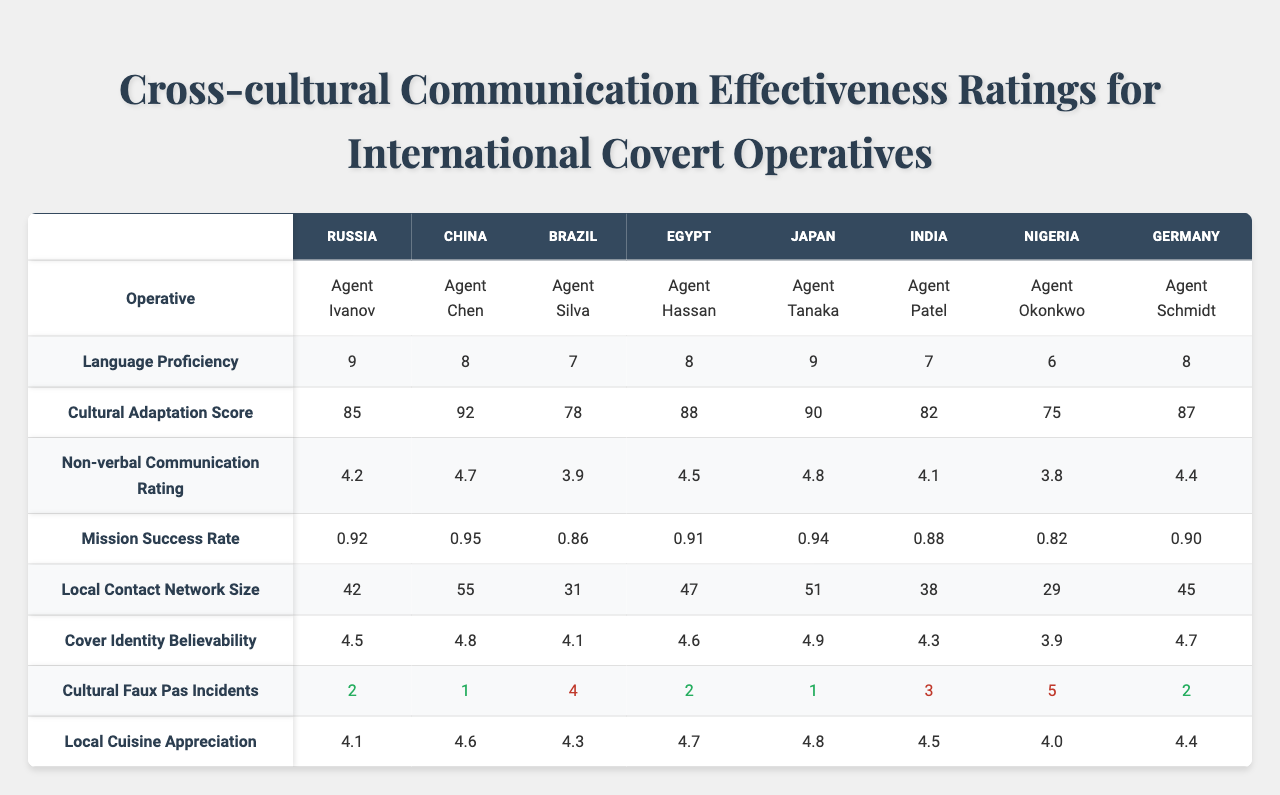What is the language proficiency rating of Agent Silva? The table shows the language proficiency ratings for each operative. For Agent Silva, the language proficiency rating is listed as 7.
Answer: 7 Which agent has the highest cultural adaptation score? The cultural adaptation scores for each agent are displayed in the table. Agent Chen has the highest score at 92.
Answer: Agent Chen What is the mission success rate of Agent Okonkwo? The mission success rate is directly shown in the table under Agent Okonkwo, which is 0.82.
Answer: 0.82 How many cultural faux pas incidents did Agent Patel have? The table lists the number of cultural faux pas incidents for each agent. Agent Patel had 3 incidents.
Answer: 3 Which agent has the best non-verbal communication rating? According to the table, Agent Tanaka has the best non-verbal communication rating at 4.8.
Answer: Agent Tanaka What is the average cultural adaptation score of all agents? To find the average, we add all the cultural adaptation scores (85 + 92 + 78 + 88 + 90 + 82 + 75 + 87) = 696, then divide by 8 (the total number of agents), resulting in an average of 87.
Answer: 87 Is Agent Hassan's cover identity believability rating higher than Agent Okonkwo's? The table shows that Agent Hassan has a rating of 4.6 and Agent Okonkwo has a rating of 4.3; thus, Agent Hassan's rating is indeed higher.
Answer: Yes How does the local contact network size of Agent Chen compare to Agent Patel? Agent Chen has a local contact network size of 55, while Agent Patel has 38. So, Agent Chen has a larger network, specifically 55 - 38 = 17 more contacts.
Answer: 17 What is the total number of cultural faux pas incidents across all agents? Summing up the incidents from the table (2 + 1 + 4 + 2 + 1 + 3 + 5 + 2) gives 20 total incidents.
Answer: 20 Which agent has the lowest local cuisine appreciation score, and what is that score? The local cuisine appreciation scores are listed, with Agent Okonkwo having the lowest score of 4.0.
Answer: Agent Okonkwo, 4.0 